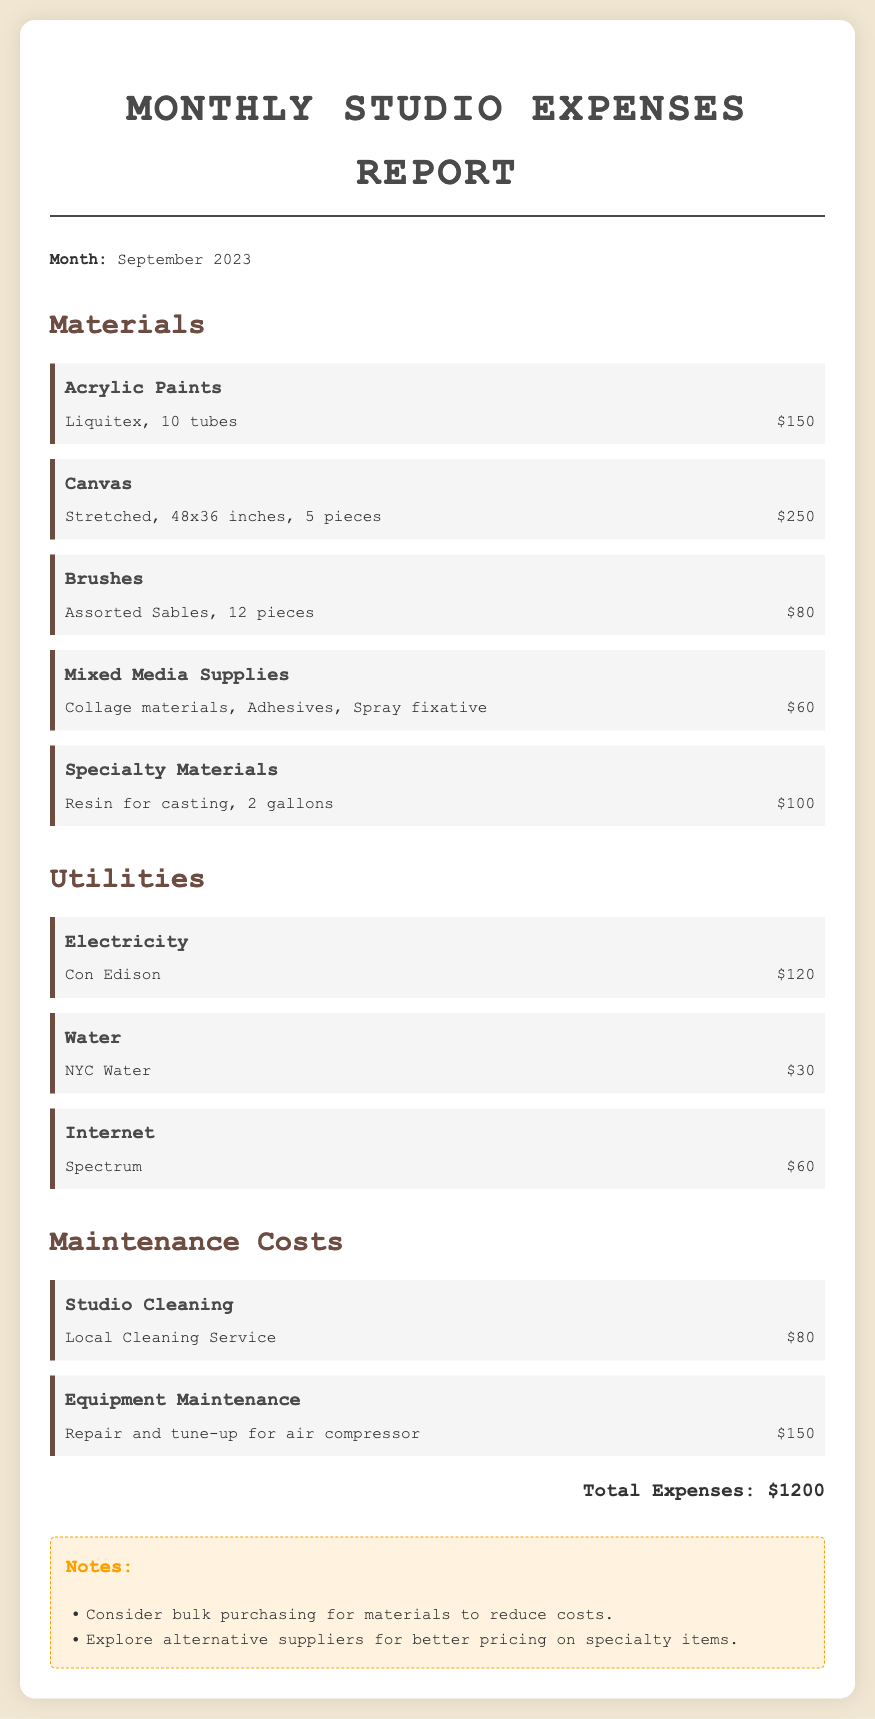What is the total amount spent on paint? The total amount spent on paint is mentioned in the materials section for acrylic paints, which is $150.
Answer: $150 How many pieces of canvas were purchased? The document states that 5 pieces of stretched canvas were purchased under the materials section.
Answer: 5 pieces What is the cost of the specialty materials? The expense details for specialty materials show a cost of $100 for resin for casting.
Answer: $100 Who provides the internet service? The internet service provider mentioned in the utilities section is Spectrum.
Answer: Spectrum What is the cost for studio cleaning? The expense of studio cleaning is listed as $80 for a local cleaning service.
Answer: $80 What is the total expense for the month? The document lists the total expenses at the bottom as $1200.
Answer: $1200 What type of supplies are included in mixed media purchases? The mixed media supplies include collage materials, adhesives, and spray fixative.
Answer: Collage materials, adhesives, spray fixative How much was spent on equipment maintenance? The document indicates that $150 was spent on the repair and tune-up for the air compressor.
Answer: $150 How much was paid for electricity? The cost for electricity is documented as $120 for Con Edison.
Answer: $120 